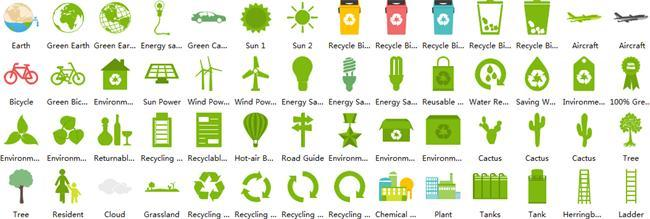how many types of cactus are shown
Answer the question with a short phrase. 3 How many symbols for recycling shown 4 What is the colour of the cycles shown, red and green or red and black red and green How many types of recycle bins are shown 5 How many globes are shown 3 What are the 2 types of renewable energy shown sun, wind 